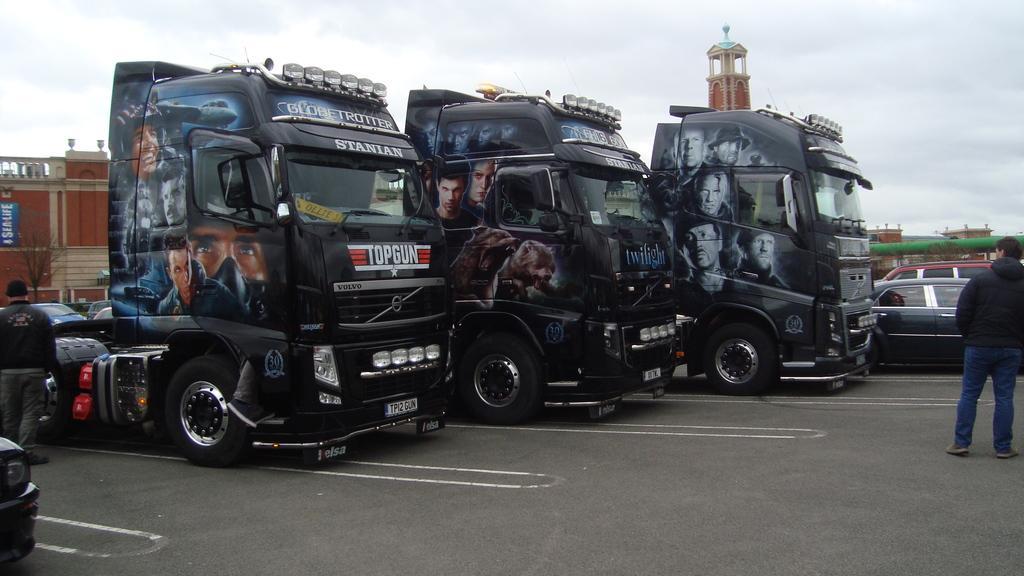How would you summarize this image in a sentence or two? In this image we can see three vehicles on a surface. On the vehicles we can see text and images. On the right side, we can see vehicles, a person and a building. On the left side, we can see a person, vehicles and a building. At the top we can see the sky. 